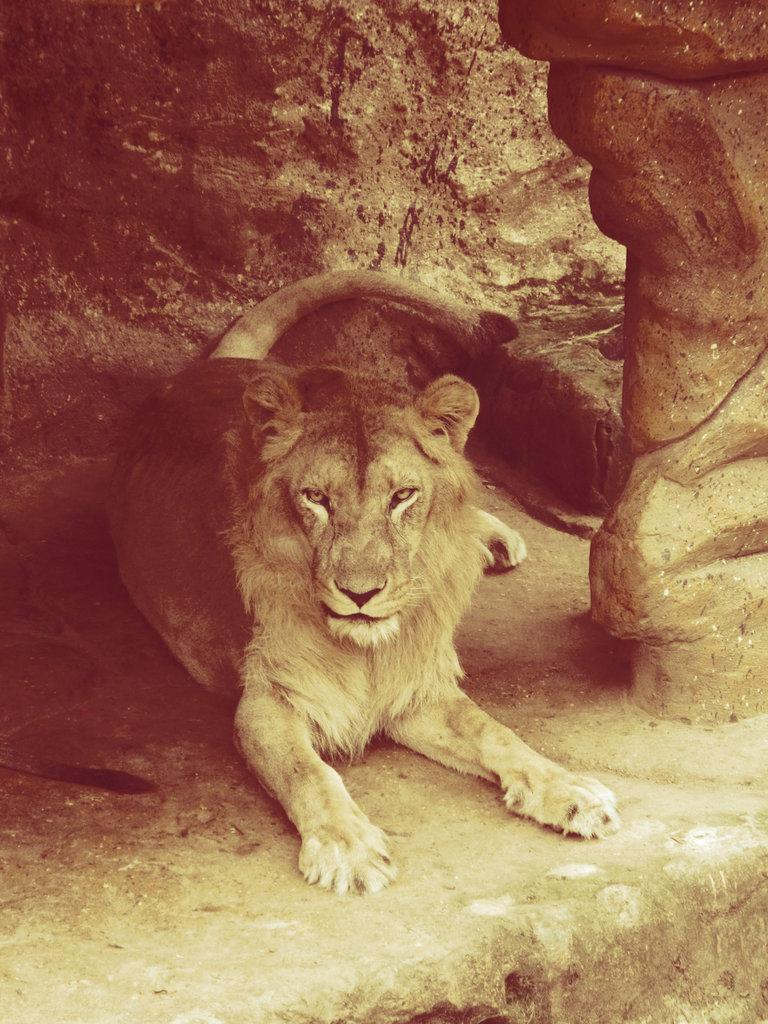What type of animal is in the image? There is a lion in the image. What can be seen in the background of the image? There is a wall in the image. How many pies are being eaten by the lion in the image? There are no pies present in the image, and the lion is not eating anything. 